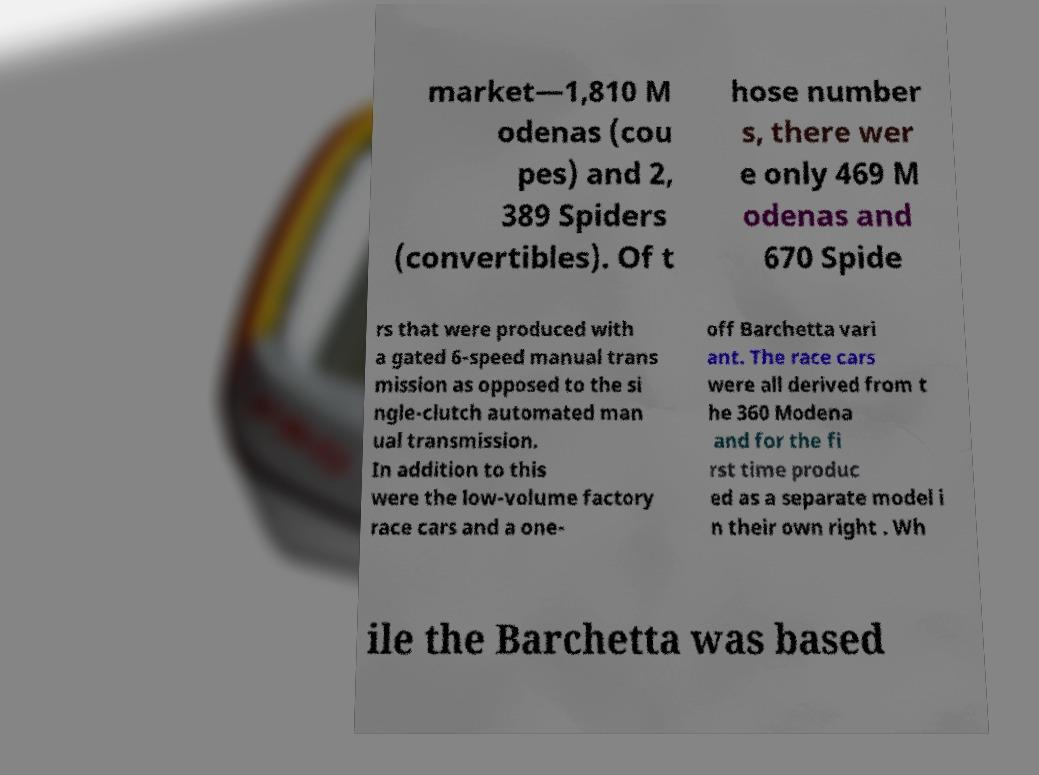Could you assist in decoding the text presented in this image and type it out clearly? market—1,810 M odenas (cou pes) and 2, 389 Spiders (convertibles). Of t hose number s, there wer e only 469 M odenas and 670 Spide rs that were produced with a gated 6-speed manual trans mission as opposed to the si ngle-clutch automated man ual transmission. In addition to this were the low-volume factory race cars and a one- off Barchetta vari ant. The race cars were all derived from t he 360 Modena and for the fi rst time produc ed as a separate model i n their own right . Wh ile the Barchetta was based 